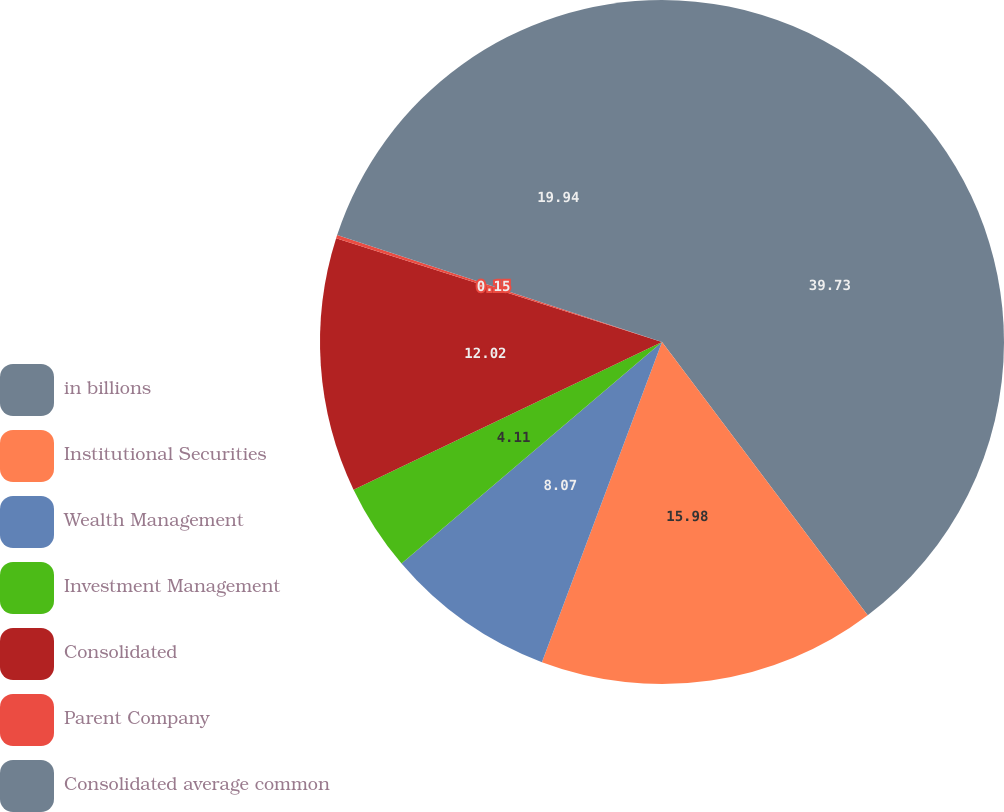<chart> <loc_0><loc_0><loc_500><loc_500><pie_chart><fcel>in billions<fcel>Institutional Securities<fcel>Wealth Management<fcel>Investment Management<fcel>Consolidated<fcel>Parent Company<fcel>Consolidated average common<nl><fcel>39.73%<fcel>15.98%<fcel>8.07%<fcel>4.11%<fcel>12.02%<fcel>0.15%<fcel>19.94%<nl></chart> 